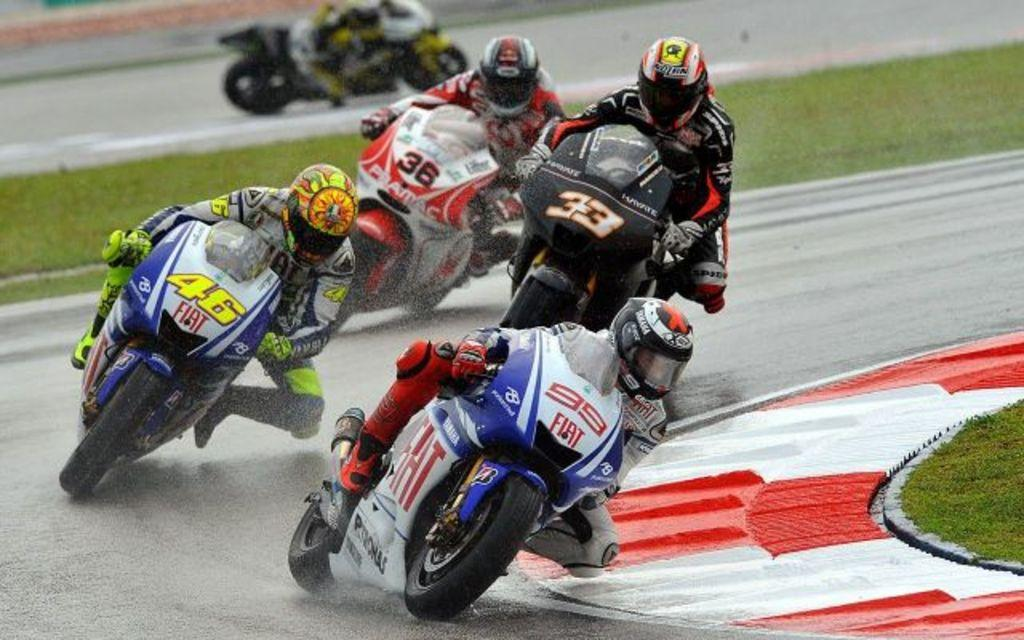Who or what is present in the image? There are people in the image. What are the people wearing on their heads? The people are wearing helmets. What type of footwear are the people wearing? The people are wearing shoes. What activity are the people engaged in? The people are riding bikes. What type of terrain can be seen in the image? There is green grass visible in the image. Can you see any ants crawling on the people's shoes in the image? There are no ants visible in the image; the focus is on the people riding bikes and wearing helmets and shoes. 